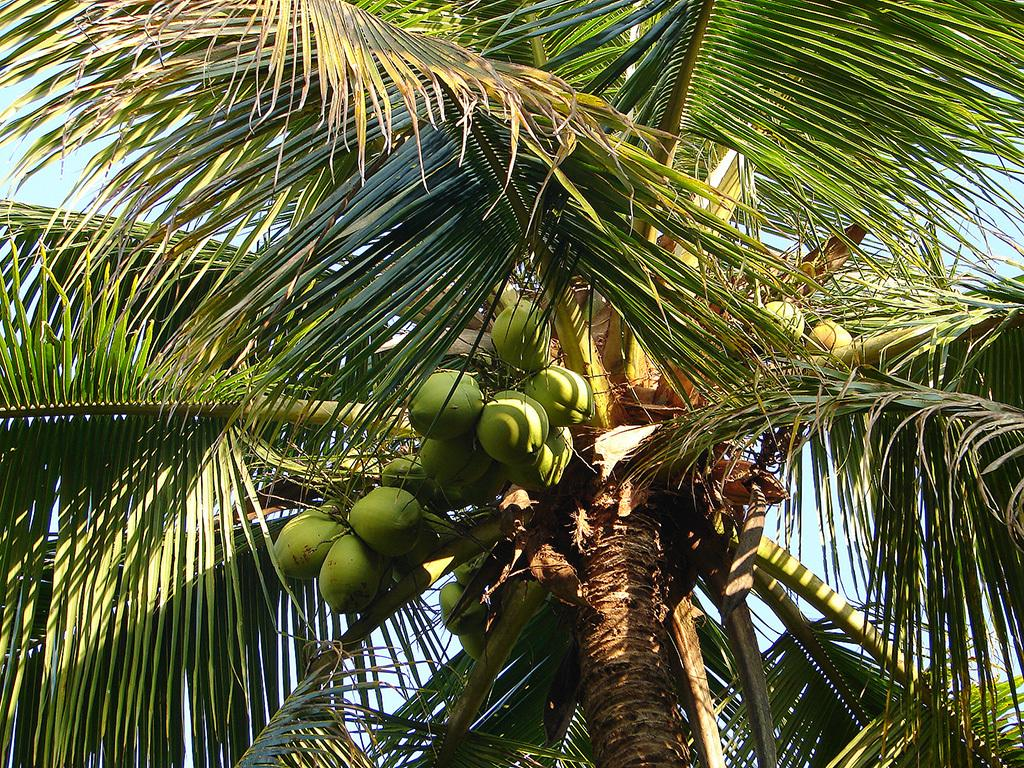What type of tree is in the image? There is a coconut tree in the image. What can be seen in the background of the image? The sky is visible in the image. Can you tell if the image was taken during the day or night? The image appears to be taken during the day. Where are the cherries hanging from the coconut tree in the image? There are no cherries present in the image; it features a coconut tree. Can you see any insects crawling on the coconut tree in the image? There is no insect present on the coconut tree in the image. 